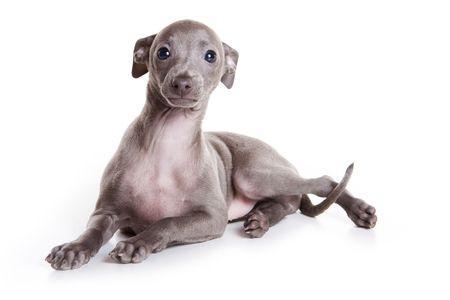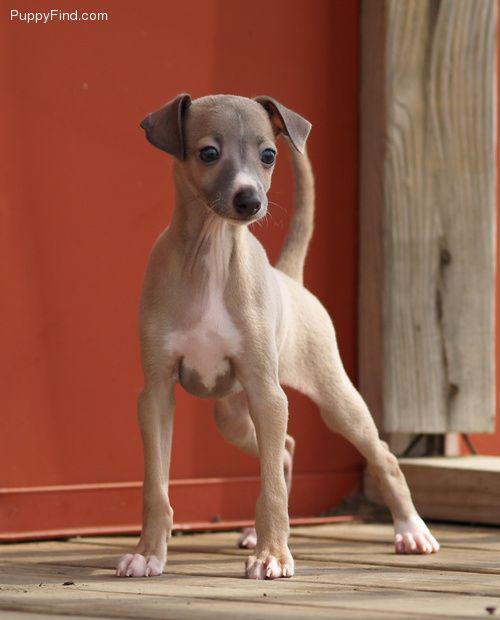The first image is the image on the left, the second image is the image on the right. Examine the images to the left and right. Is the description "All images show one dog, with the dog on the right standing indoors." accurate? Answer yes or no. Yes. The first image is the image on the left, the second image is the image on the right. Given the left and right images, does the statement "the dog in the image on the right is standing on all fours" hold true? Answer yes or no. Yes. 